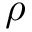<formula> <loc_0><loc_0><loc_500><loc_500>\rho</formula> 